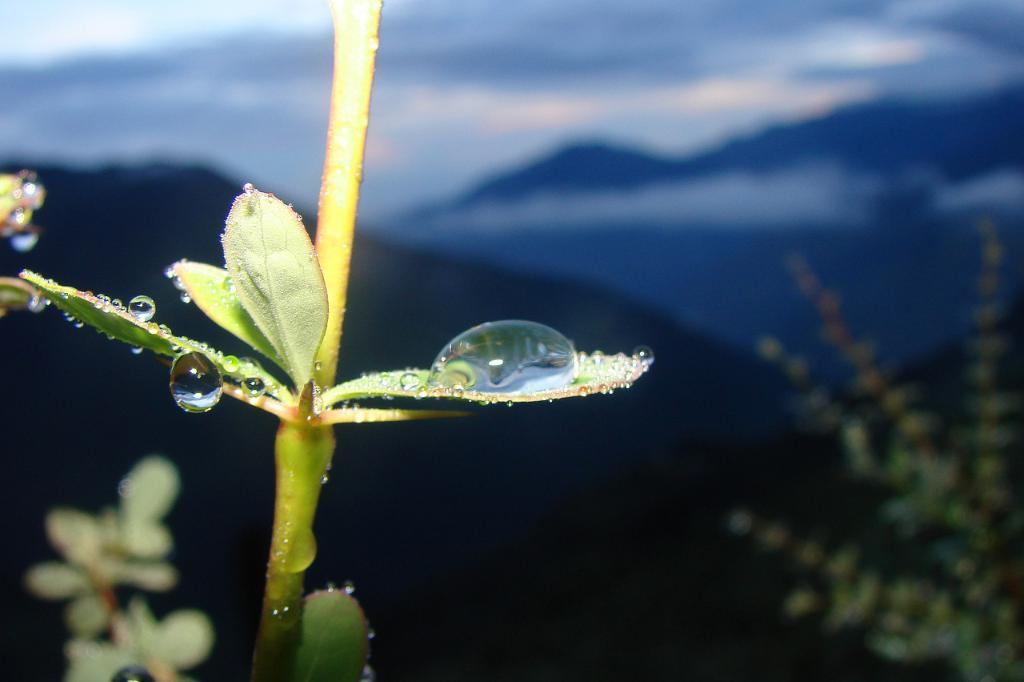What is the condition of the plant in the image? There are water droplets on a plant in the image. Where is the plant located in the image? The plant is on the left side of the image. What is visible at the top of the image? The sky is visible at the top of the image. What type of stamp can be seen on the creator's scarf in the image? There is no creator or scarf present in the image; it features a plant with water droplets and a visible sky. 